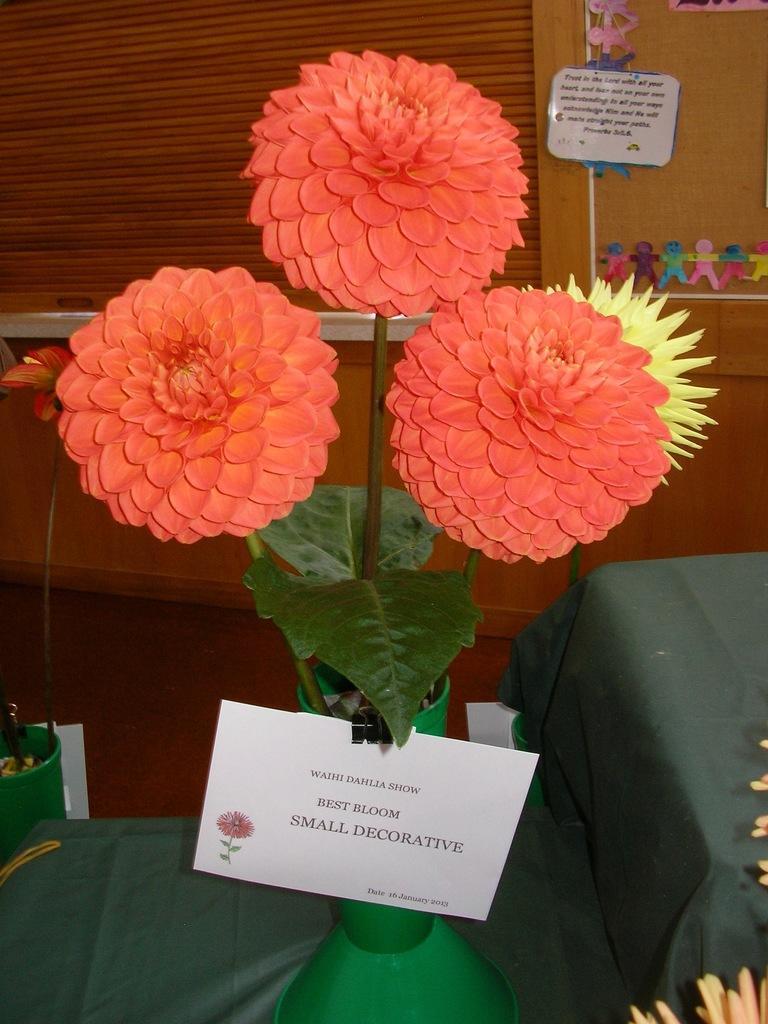Could you give a brief overview of what you see in this image? In this image there is a flower pot in the middle. In the flower pot there are four flowers. In the background there is a curtain. There is a card attached to the flower vase. On the right side top there is some decoration on the wall. 